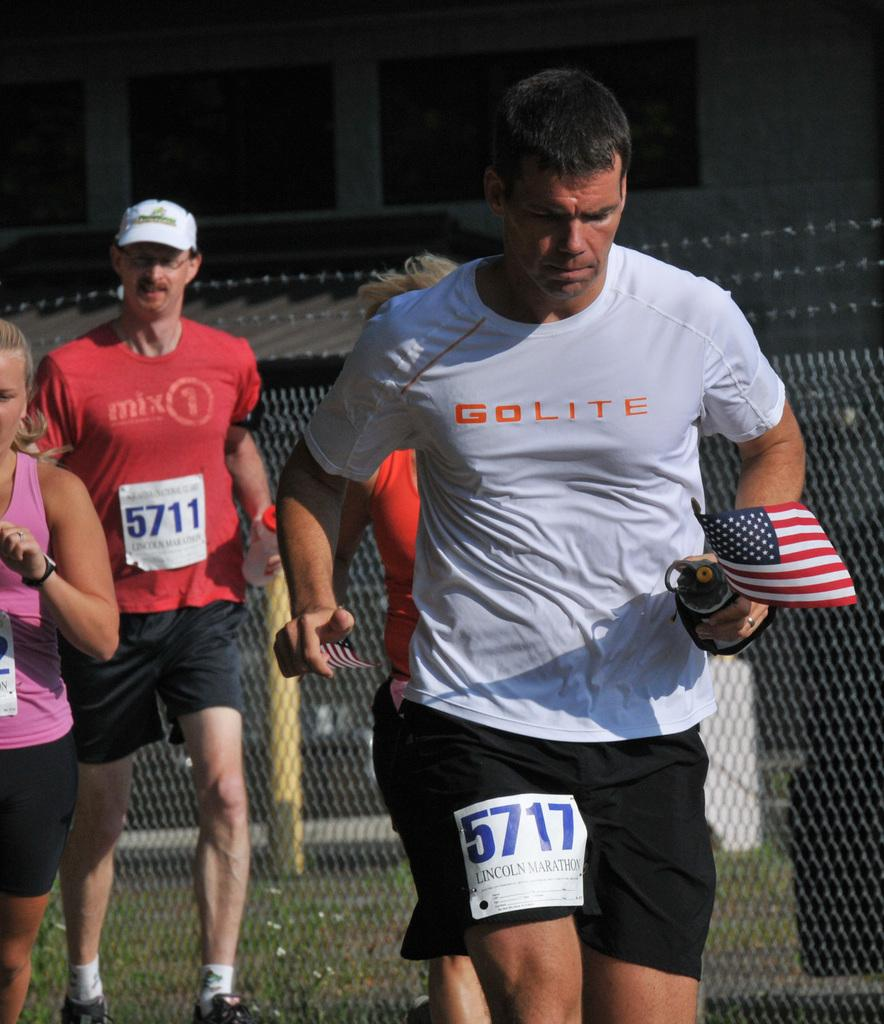What are the people in the image doing? There are many people running in the image. Can you describe the person in the foreground? The person in the foreground is holding an American flag. What type of station can be seen in the background of the image? There is no station visible in the background of the image. How many stars are present on the American flag held by the person in the foreground? The American flag held by the person in the foreground has 50 stars, but this detail is not mentioned in the provided facts. 